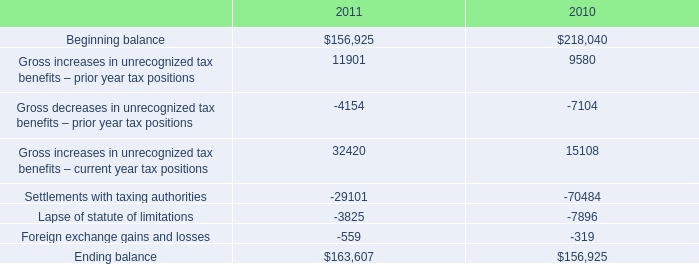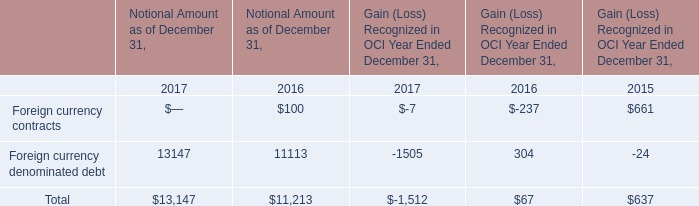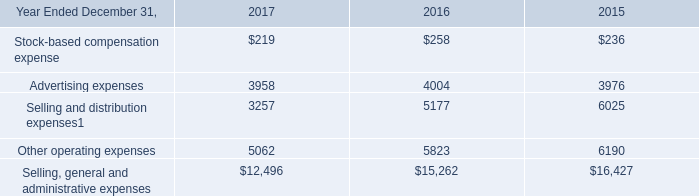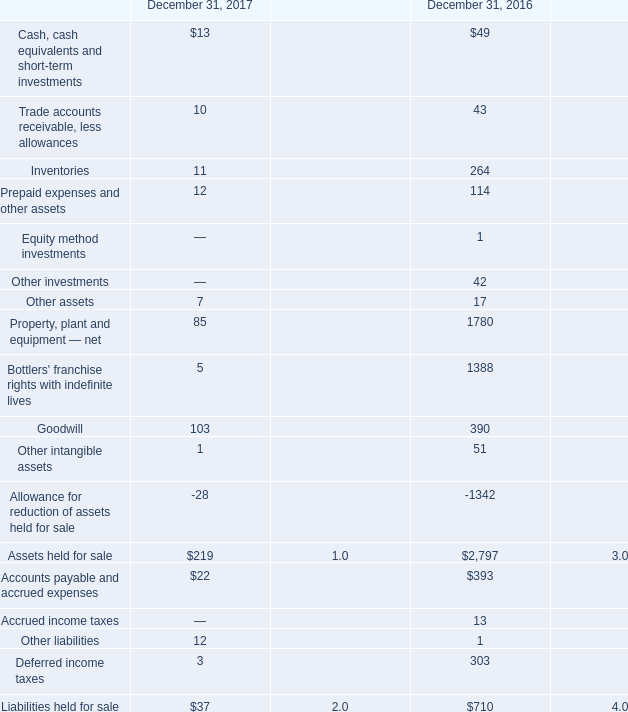what is the growth rate in the balance of unrecognized tax benefits during 2011? 
Computations: ((163607 - 156925) / 156925)
Answer: 0.04258. 